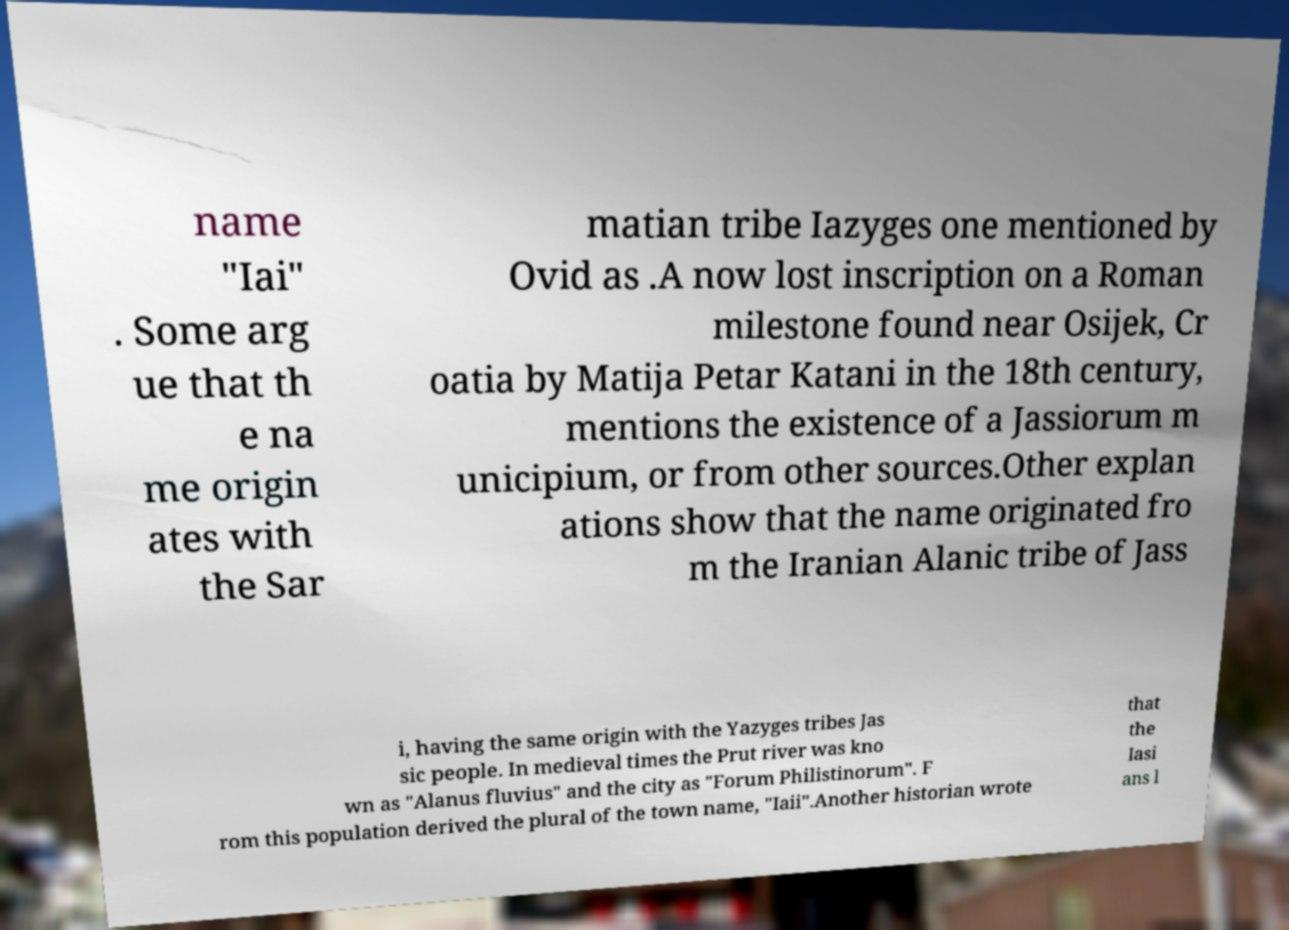For documentation purposes, I need the text within this image transcribed. Could you provide that? name "Iai" . Some arg ue that th e na me origin ates with the Sar matian tribe Iazyges one mentioned by Ovid as .A now lost inscription on a Roman milestone found near Osijek, Cr oatia by Matija Petar Katani in the 18th century, mentions the existence of a Jassiorum m unicipium, or from other sources.Other explan ations show that the name originated fro m the Iranian Alanic tribe of Jass i, having the same origin with the Yazyges tribes Jas sic people. In medieval times the Prut river was kno wn as "Alanus fluvius" and the city as "Forum Philistinorum". F rom this population derived the plural of the town name, "Iaii".Another historian wrote that the Iasi ans l 